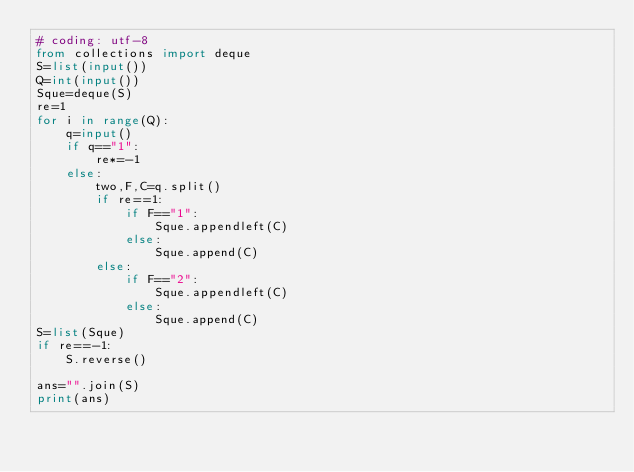<code> <loc_0><loc_0><loc_500><loc_500><_Python_># coding: utf-8
from collections import deque
S=list(input())
Q=int(input())
Sque=deque(S)
re=1
for i in range(Q):
    q=input()
    if q=="1":
        re*=-1
    else:
        two,F,C=q.split()
        if re==1:
            if F=="1":
                Sque.appendleft(C)
            else:
                Sque.append(C)
        else:
            if F=="2":
                Sque.appendleft(C)
            else:
                Sque.append(C)
S=list(Sque)
if re==-1:
    S.reverse()

ans="".join(S)
print(ans)

</code> 